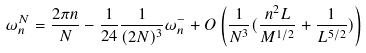Convert formula to latex. <formula><loc_0><loc_0><loc_500><loc_500>\omega _ { n } ^ { N } = \frac { 2 \pi n } { N } - \frac { 1 } { 2 4 } \frac { 1 } { ( 2 N ) ^ { 3 } } \omega ^ { - } _ { n } + O \left ( \frac { 1 } { N ^ { 3 } } ( \frac { n ^ { 2 } L } { M ^ { 1 / 2 } } + \frac { 1 } { L ^ { 5 / 2 } } ) \right )</formula> 